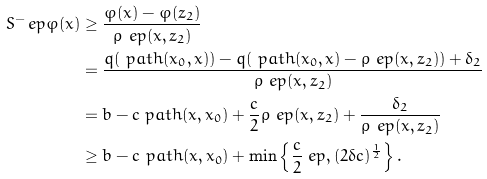Convert formula to latex. <formula><loc_0><loc_0><loc_500><loc_500>S ^ { - } _ { \ } e p \varphi ( x ) & \geq \frac { \varphi ( x ) - \varphi ( z _ { 2 } ) } { \rho _ { \ } e p ( x , z _ { 2 } ) } \\ & = \frac { q ( \ p a t h ( x _ { 0 } , x ) ) - q ( \ p a t h ( x _ { 0 } , x ) - \rho _ { \ } e p ( x , z _ { 2 } ) ) + \delta _ { 2 } } { \rho _ { \ } e p ( x , z _ { 2 } ) } \\ & = b - c \ p a t h ( x , x _ { 0 } ) + \frac { c } { 2 } \rho _ { \ } e p ( x , z _ { 2 } ) + \frac { \delta _ { 2 } } { \rho _ { \ } e p ( x , z _ { 2 } ) } \\ & \geq b - c \ p a t h ( x , x _ { 0 } ) + \min \left \{ \frac { c } { 2 } \ e p , ( 2 \delta c ) ^ { \frac { 1 } { 2 } } \right \} .</formula> 